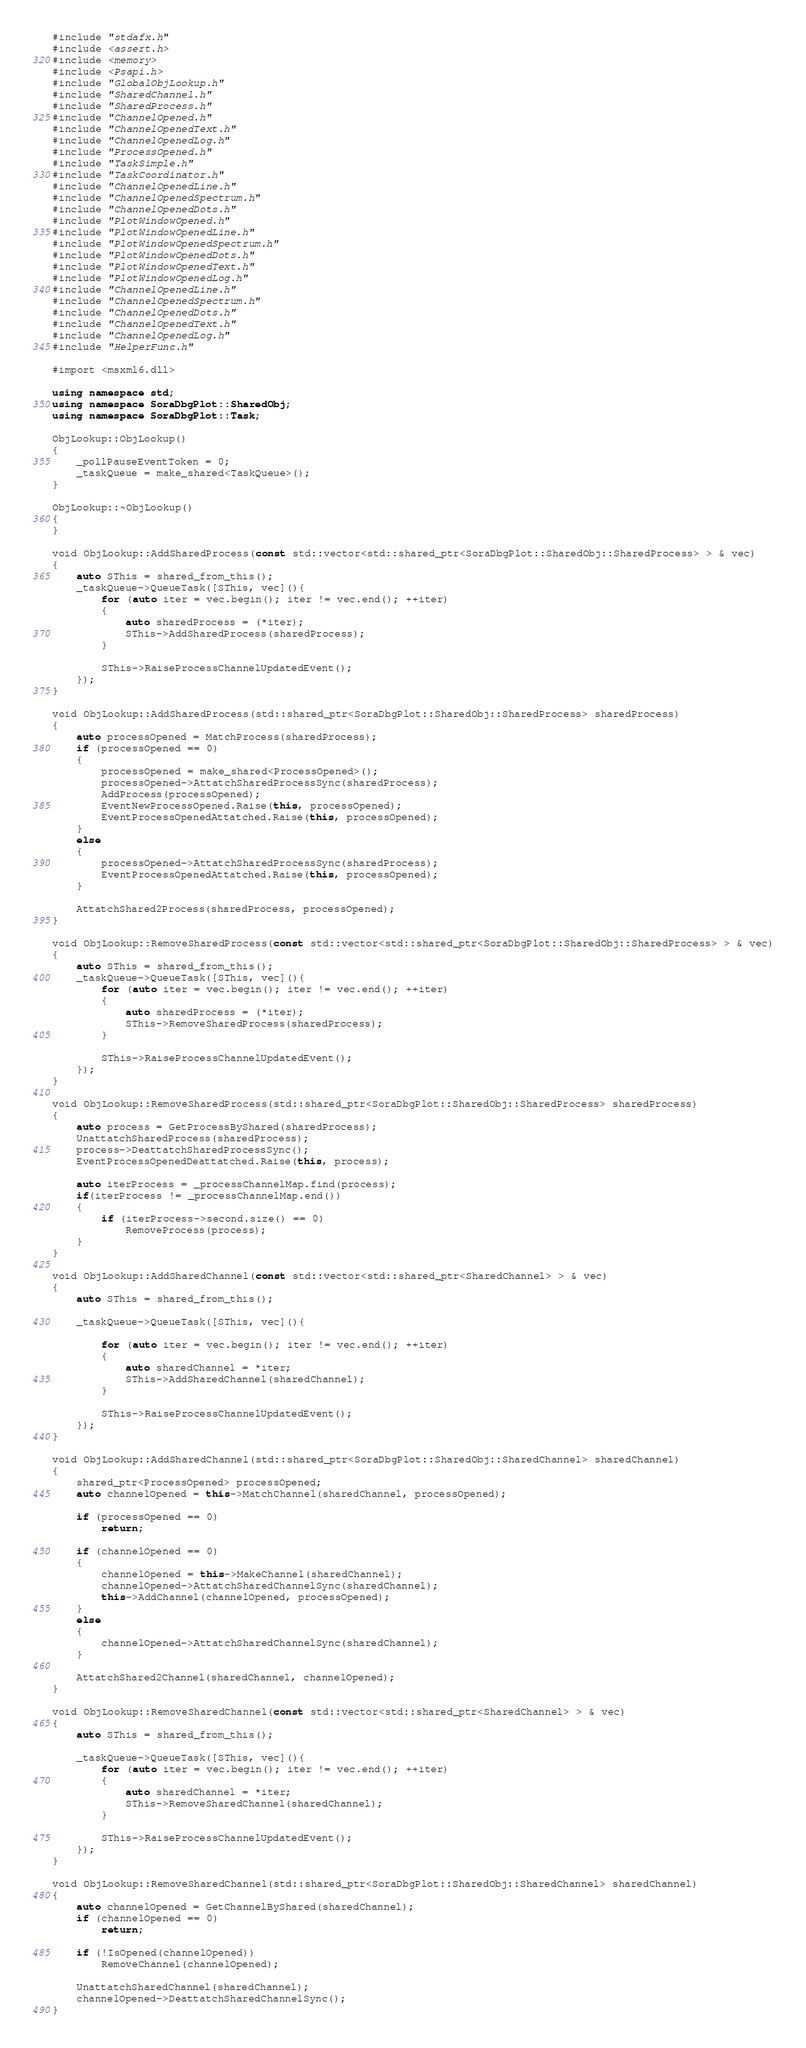Convert code to text. <code><loc_0><loc_0><loc_500><loc_500><_C++_>#include "stdafx.h"
#include <assert.h>
#include <memory>
#include <Psapi.h>
#include "GlobalObjLookup.h"
#include "SharedChannel.h"
#include "SharedProcess.h"
#include "ChannelOpened.h"
#include "ChannelOpenedText.h"
#include "ChannelOpenedLog.h"
#include "ProcessOpened.h"
#include "TaskSimple.h"
#include "TaskCoordinator.h"
#include "ChannelOpenedLine.h"
#include "ChannelOpenedSpectrum.h"
#include "ChannelOpenedDots.h"
#include "PlotWindowOpened.h"
#include "PlotWindowOpenedLine.h"
#include "PlotWindowOpenedSpectrum.h"
#include "PlotWindowOpenedDots.h"
#include "PlotWindowOpenedText.h"
#include "PlotWindowOpenedLog.h"
#include "ChannelOpenedLine.h"
#include "ChannelOpenedSpectrum.h"
#include "ChannelOpenedDots.h"
#include "ChannelOpenedText.h"
#include "ChannelOpenedLog.h"
#include "HelperFunc.h"

#import <msxml6.dll>

using namespace std;
using namespace SoraDbgPlot::SharedObj;
using namespace SoraDbgPlot::Task;

ObjLookup::ObjLookup()
{
	_pollPauseEventToken = 0;
	_taskQueue = make_shared<TaskQueue>();
}

ObjLookup::~ObjLookup()
{
}

void ObjLookup::AddSharedProcess(const std::vector<std::shared_ptr<SoraDbgPlot::SharedObj::SharedProcess> > & vec)
{
	auto SThis = shared_from_this();
	_taskQueue->QueueTask([SThis, vec](){
		for (auto iter = vec.begin(); iter != vec.end(); ++iter)
		{
			auto sharedProcess = (*iter);
			SThis->AddSharedProcess(sharedProcess);
		}

		SThis->RaiseProcessChannelUpdatedEvent();
	});
}

void ObjLookup::AddSharedProcess(std::shared_ptr<SoraDbgPlot::SharedObj::SharedProcess> sharedProcess)
{
	auto processOpened = MatchProcess(sharedProcess);
	if (processOpened == 0)
	{
		processOpened = make_shared<ProcessOpened>();
		processOpened->AttatchSharedProcessSync(sharedProcess);
		AddProcess(processOpened);
		EventNewProcessOpened.Raise(this, processOpened);
		EventProcessOpenedAttatched.Raise(this, processOpened);
	}
	else
	{
		processOpened->AttatchSharedProcessSync(sharedProcess);
		EventProcessOpenedAttatched.Raise(this, processOpened);
	}
	
	AttatchShared2Process(sharedProcess, processOpened);
}

void ObjLookup::RemoveSharedProcess(const std::vector<std::shared_ptr<SoraDbgPlot::SharedObj::SharedProcess> > & vec)
{
	auto SThis = shared_from_this();
	_taskQueue->QueueTask([SThis, vec](){
		for (auto iter = vec.begin(); iter != vec.end(); ++iter)
		{
			auto sharedProcess = (*iter);
			SThis->RemoveSharedProcess(sharedProcess);
		}

		SThis->RaiseProcessChannelUpdatedEvent();
	});
}

void ObjLookup::RemoveSharedProcess(std::shared_ptr<SoraDbgPlot::SharedObj::SharedProcess> sharedProcess)
{
	auto process = GetProcessByShared(sharedProcess);
	UnattatchSharedProcess(sharedProcess);
	process->DeattatchSharedProcessSync();
	EventProcessOpenedDeattatched.Raise(this, process);

	auto iterProcess = _processChannelMap.find(process);
	if(iterProcess != _processChannelMap.end())
	{
		if (iterProcess->second.size() == 0)
			RemoveProcess(process);
	}
}

void ObjLookup::AddSharedChannel(const std::vector<std::shared_ptr<SharedChannel> > & vec)
{
	auto SThis = shared_from_this();

	_taskQueue->QueueTask([SThis, vec](){

		for (auto iter = vec.begin(); iter != vec.end(); ++iter)
		{
			auto sharedChannel = *iter;
			SThis->AddSharedChannel(sharedChannel);
		}

		SThis->RaiseProcessChannelUpdatedEvent();
	});
}

void ObjLookup::AddSharedChannel(std::shared_ptr<SoraDbgPlot::SharedObj::SharedChannel> sharedChannel)
{
	shared_ptr<ProcessOpened> processOpened;
	auto channelOpened = this->MatchChannel(sharedChannel, processOpened);

	if (processOpened == 0)
		return;

	if (channelOpened == 0)
	{
		channelOpened = this->MakeChannel(sharedChannel);
		channelOpened->AttatchSharedChannelSync(sharedChannel);	
		this->AddChannel(channelOpened, processOpened);
	}
	else
	{
		channelOpened->AttatchSharedChannelSync(sharedChannel);	
	}

	AttatchShared2Channel(sharedChannel, channelOpened);
}

void ObjLookup::RemoveSharedChannel(const std::vector<std::shared_ptr<SharedChannel> > & vec)
{
	auto SThis = shared_from_this();

	_taskQueue->QueueTask([SThis, vec](){		
		for (auto iter = vec.begin(); iter != vec.end(); ++iter)
		{
			auto sharedChannel = *iter;
			SThis->RemoveSharedChannel(sharedChannel);
		}

		SThis->RaiseProcessChannelUpdatedEvent();
	});
}

void ObjLookup::RemoveSharedChannel(std::shared_ptr<SoraDbgPlot::SharedObj::SharedChannel> sharedChannel)
{
	auto channelOpened = GetChannelByShared(sharedChannel);
	if (channelOpened == 0)
		return;

	if (!IsOpened(channelOpened))
		RemoveChannel(channelOpened);

	UnattatchSharedChannel(sharedChannel);
	channelOpened->DeattatchSharedChannelSync();
}
</code> 